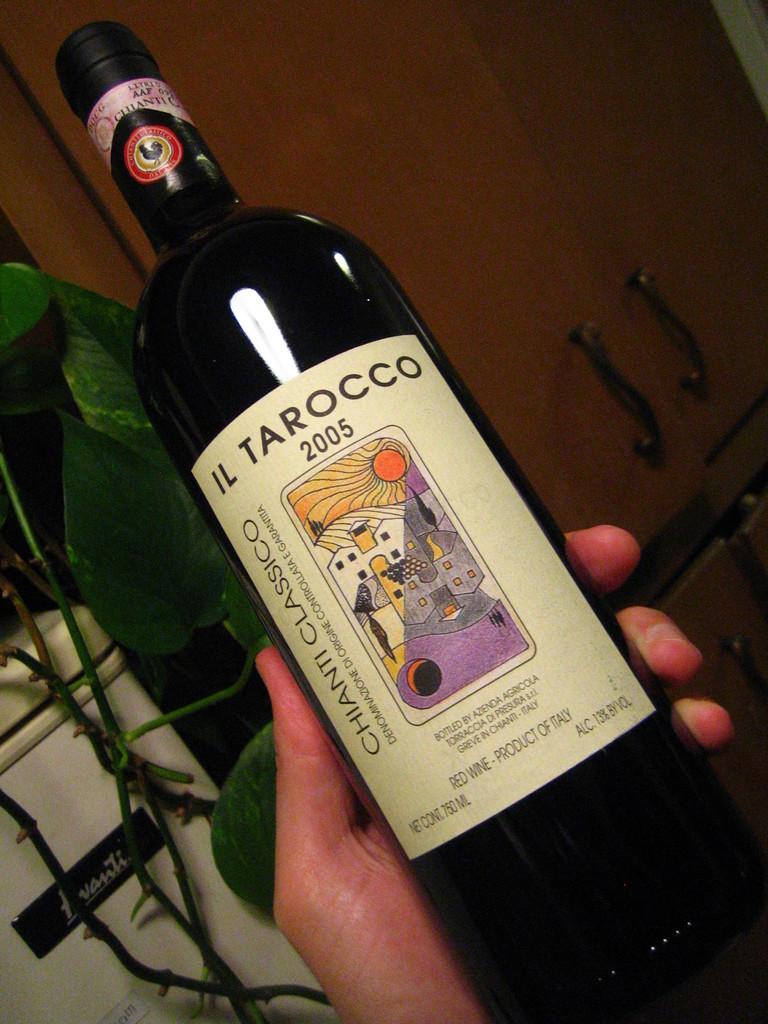What brand is it?
Keep it short and to the point. Il tarocco. 